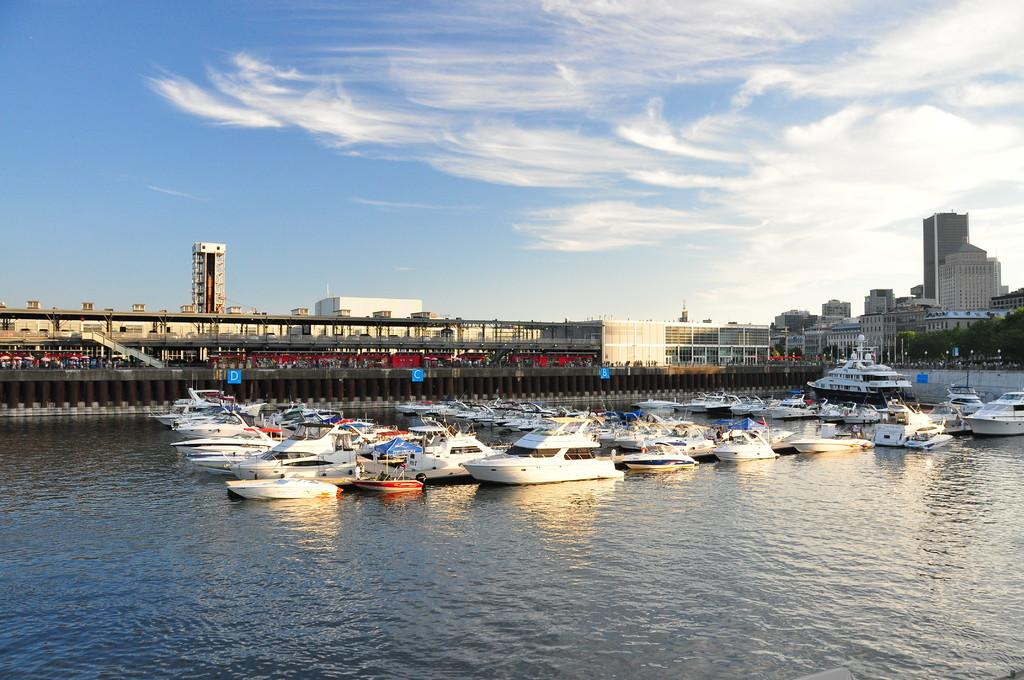What is the main subject of the image? The main subject of the image is ships. What can be seen in the background of the image? There is water, buildings, and trees visible in the image. What is the color of the boards on the pillars? The color boards on the pillars are blue. What is the color of the sky in the image? The sky is in blue and white color. What type of current is flowing through the ships in the image? There is no indication of a current in the image; it only shows ships on water. How is the hate being expressed in the image? There is no hate present in the image; it features ships, water, buildings, trees, and blue color boards on pillars. 